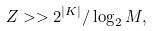Convert formula to latex. <formula><loc_0><loc_0><loc_500><loc_500>Z > > 2 ^ { | K | } / \log _ { 2 } M ,</formula> 